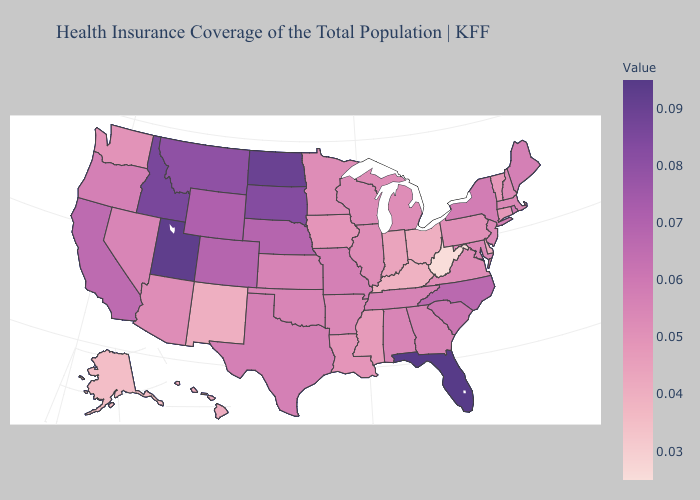Does Delaware have a lower value than Oklahoma?
Give a very brief answer. Yes. Among the states that border Ohio , which have the highest value?
Give a very brief answer. Michigan. Does Oregon have the lowest value in the West?
Short answer required. No. Is the legend a continuous bar?
Be succinct. Yes. Does West Virginia have the lowest value in the USA?
Write a very short answer. Yes. 